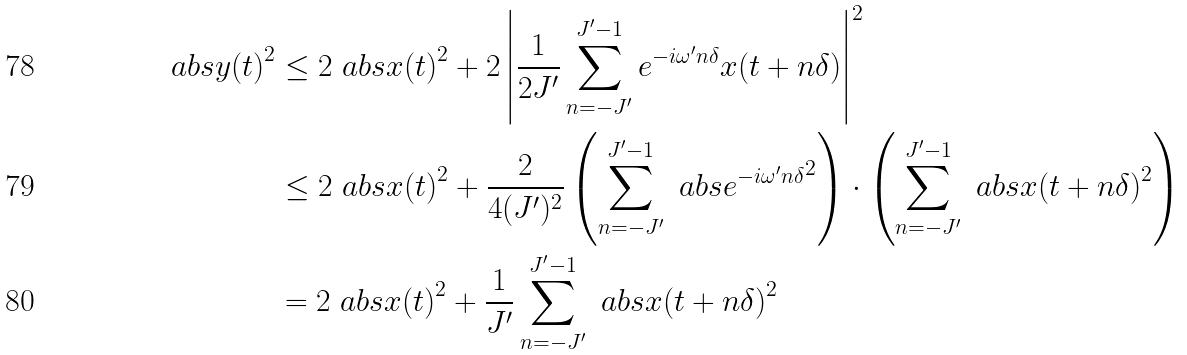<formula> <loc_0><loc_0><loc_500><loc_500>\ a b s { y ( t ) } ^ { 2 } & \leq 2 \ a b s { x ( t ) } ^ { 2 } + 2 \left | \frac { 1 } { 2 J ^ { \prime } } \sum _ { n = - J ^ { \prime } } ^ { J ^ { \prime } - 1 } e ^ { - i \omega ^ { \prime } n \delta } x ( t + n \delta ) \right | ^ { 2 } \\ & \leq 2 \ a b s { x ( t ) } ^ { 2 } + \frac { 2 } { 4 ( J ^ { \prime } ) ^ { 2 } } \left ( \sum _ { n = - J ^ { \prime } } ^ { J ^ { \prime } - 1 } \ a b s { e ^ { - i \omega ^ { \prime } n \delta } } ^ { 2 } \right ) \cdot \left ( \sum _ { n = - J ^ { \prime } } ^ { J ^ { \prime } - 1 } \ a b s { x ( t + n \delta ) } ^ { 2 } \right ) \\ & = 2 \ a b s { x ( t ) } ^ { 2 } + \frac { 1 } { J ^ { \prime } } \sum _ { n = - J ^ { \prime } } ^ { J ^ { \prime } - 1 } \ a b s { x ( t + n \delta ) } ^ { 2 }</formula> 